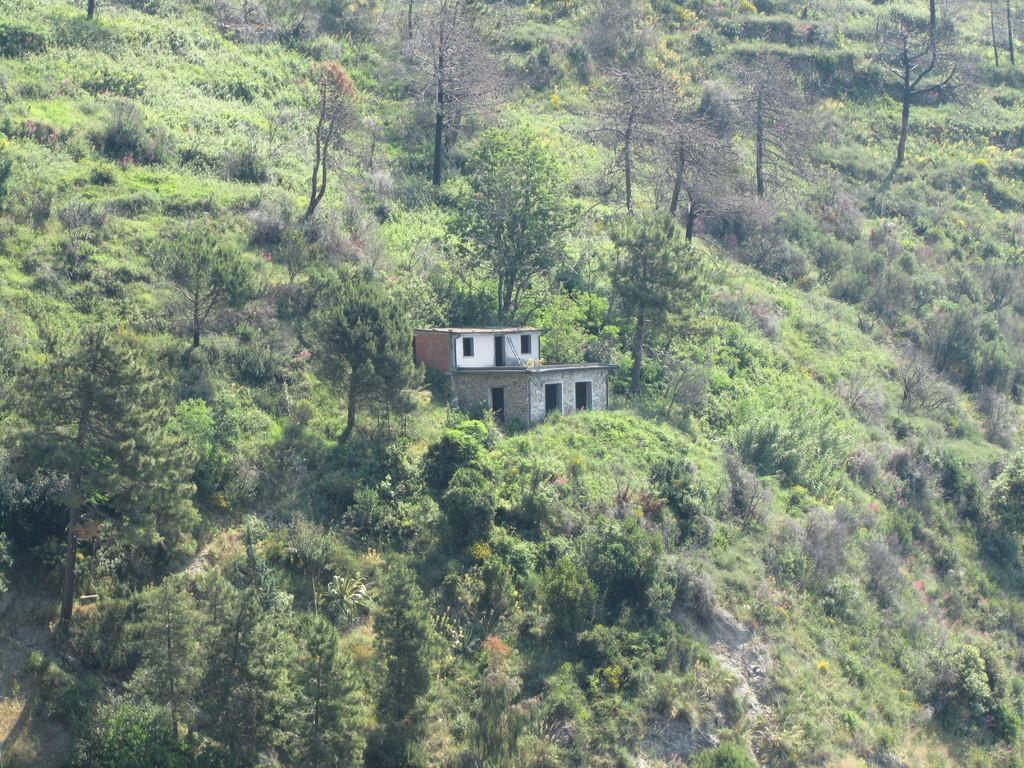Can you describe this image briefly? In this image I can see a huge mountain on which I can see few trees which are green, brown, ash and black in color. I can see a building which is white, brown and ash in color. 